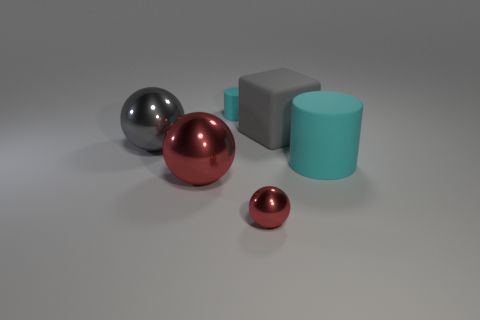How many purple things are large matte things or large objects? There are no large matte purple things or large purple objects in the image. The objects in the image appear to be comprised of smaller and larger spheres and cubes, in shades of red, silver, and teal, with varying finishes like reflective or matte, but there are no large purple things visible. 